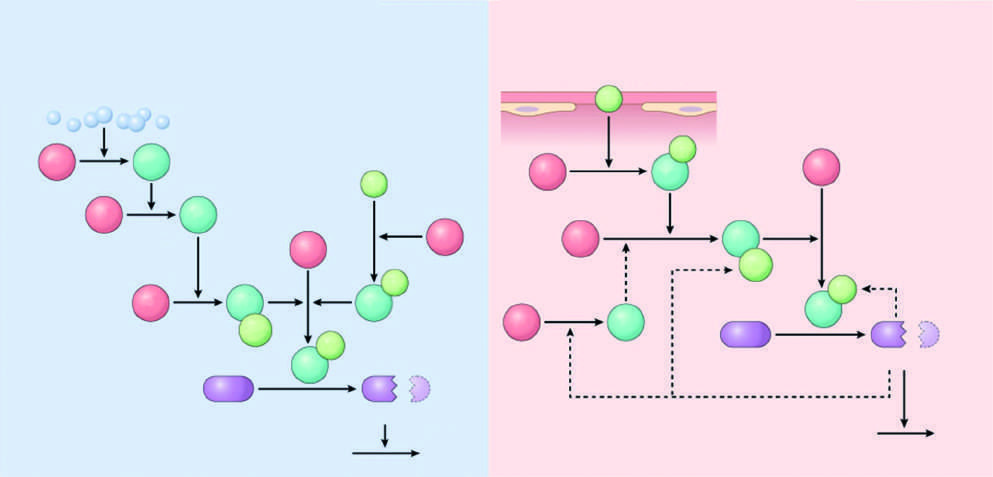what is the major initiator of coagulation?
Answer the question using a single word or phrase. Tissue factor 